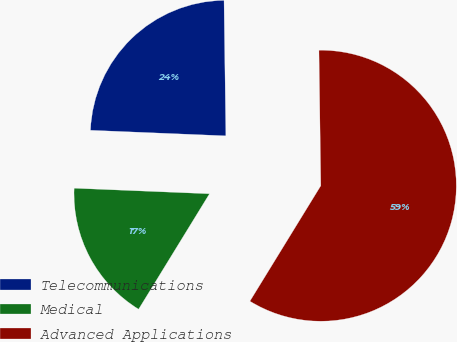<chart> <loc_0><loc_0><loc_500><loc_500><pie_chart><fcel>Telecommunications<fcel>Medical<fcel>Advanced Applications<nl><fcel>24.13%<fcel>16.89%<fcel>58.98%<nl></chart> 